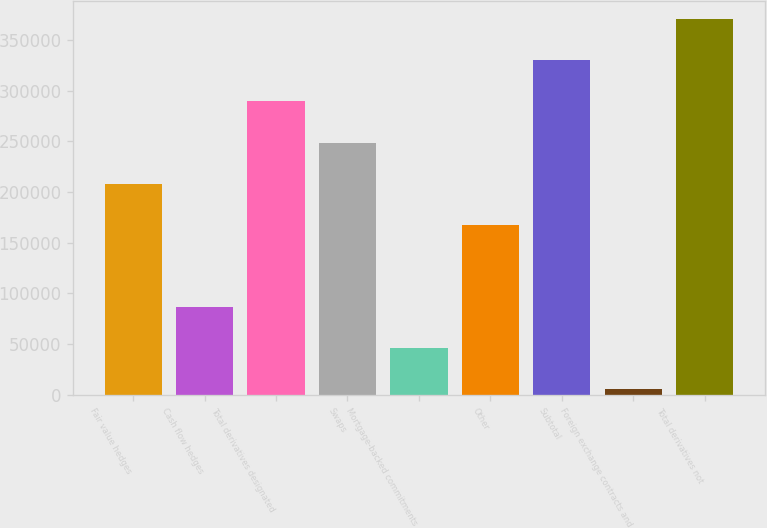<chart> <loc_0><loc_0><loc_500><loc_500><bar_chart><fcel>Fair value hedges<fcel>Cash flow hedges<fcel>Total derivatives designated<fcel>Swaps<fcel>Mortgage-backed commitments<fcel>Other<fcel>Subtotal<fcel>Foreign exchange contracts and<fcel>Total derivatives not<nl><fcel>208192<fcel>86625.4<fcel>289236<fcel>248714<fcel>46103.2<fcel>167670<fcel>329759<fcel>5581<fcel>370281<nl></chart> 